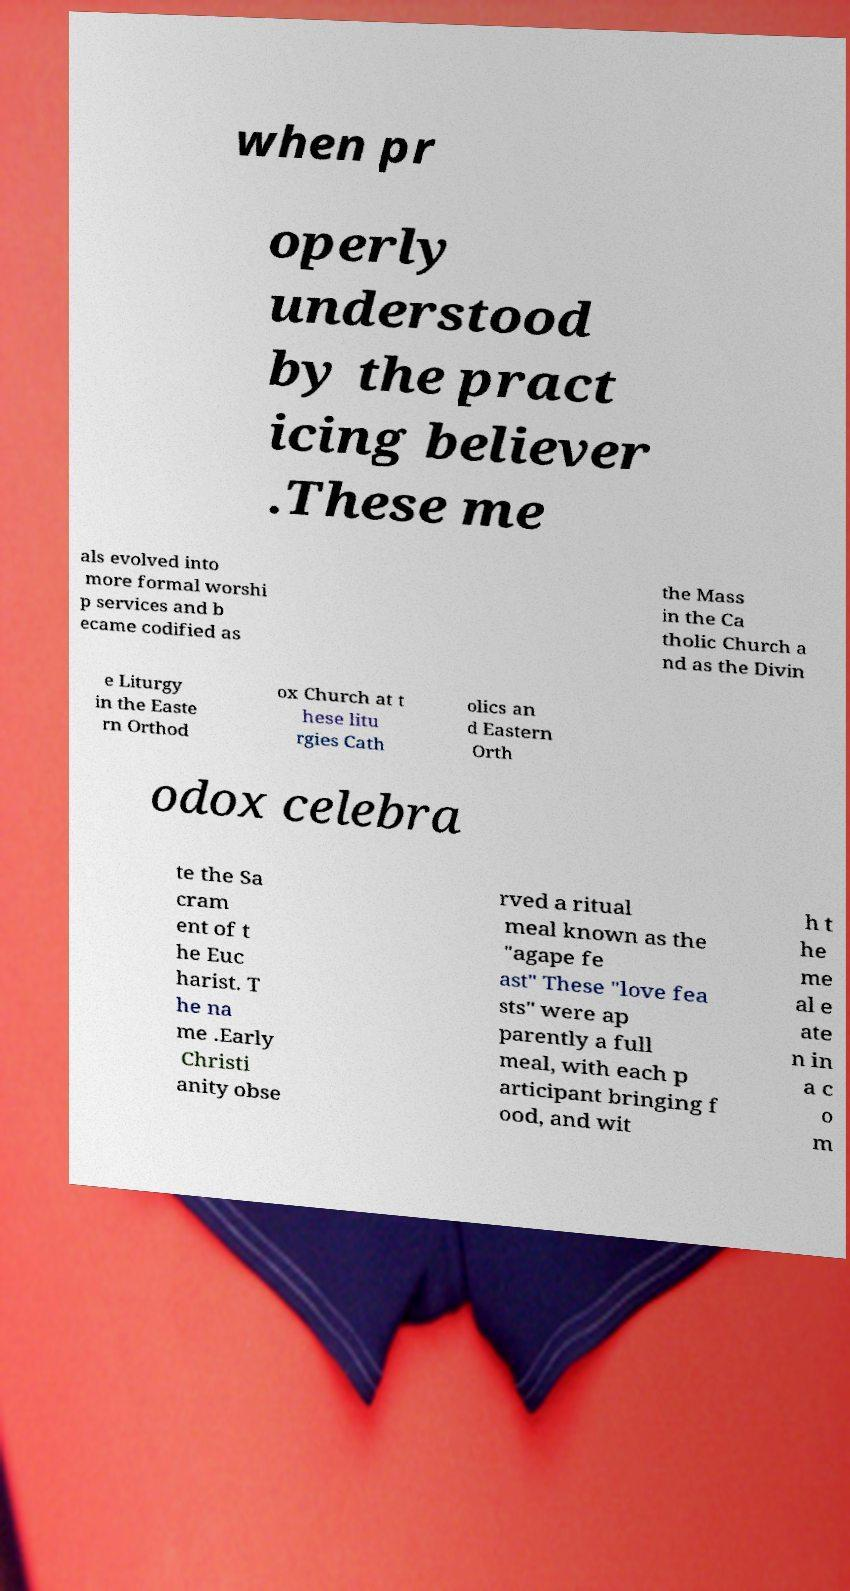I need the written content from this picture converted into text. Can you do that? when pr operly understood by the pract icing believer .These me als evolved into more formal worshi p services and b ecame codified as the Mass in the Ca tholic Church a nd as the Divin e Liturgy in the Easte rn Orthod ox Church at t hese litu rgies Cath olics an d Eastern Orth odox celebra te the Sa cram ent of t he Euc harist. T he na me .Early Christi anity obse rved a ritual meal known as the "agape fe ast" These "love fea sts" were ap parently a full meal, with each p articipant bringing f ood, and wit h t he me al e ate n in a c o m 